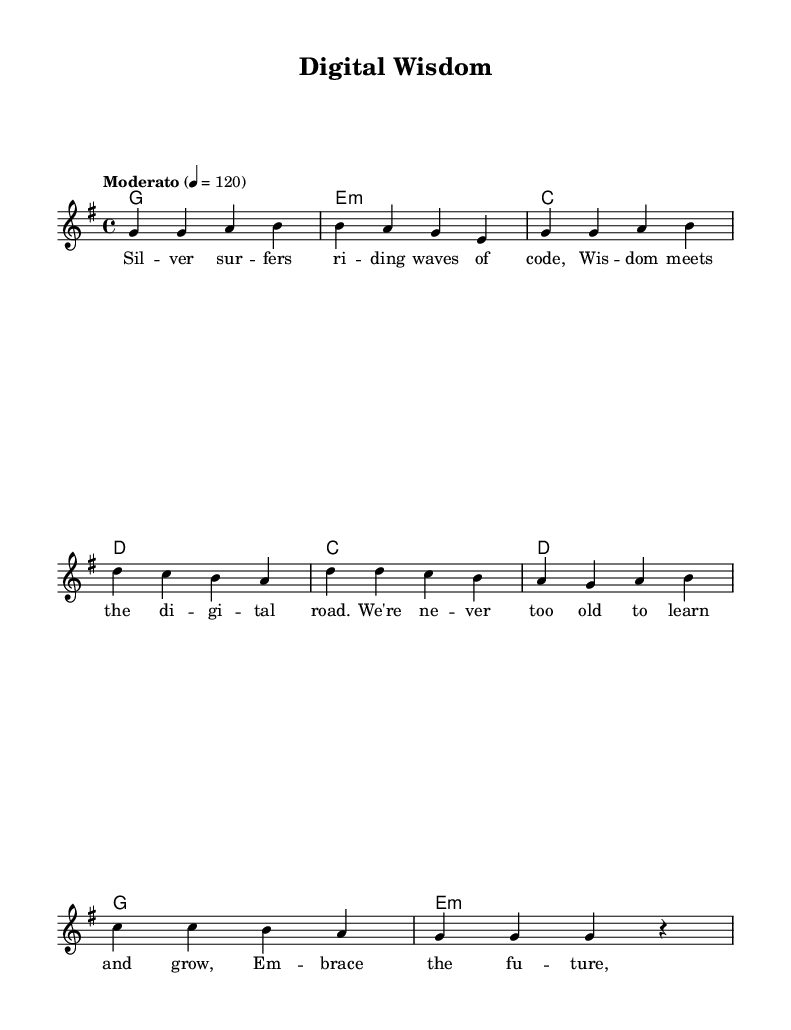What is the key signature of this music? The key signature is G major, which has one sharp (F#). This can be determined by looking at the key signature shown at the beginning of the staff.
Answer: G major What is the time signature of this music? The time signature is 4/4, indicating there are four beats in each measure and the quarter note receives one beat. This is indicated at the beginning of the sheet.
Answer: 4/4 What is the tempo marking in this music? The tempo marking is "Moderato," which typically suggests a moderate speed. The number 120 indicates the beats per minute (quarter note).
Answer: Moderato How many measures are in the verse section? The verse section contains four measures, which can be counted by observing the number of vertical lines separating the notes.
Answer: Four What chord follows the G major chord in the verse? The chord that follows the G major chord is E minor, as indicated in the chord changes written above the staff during the verse section.
Answer: E minor What are the lyrics associated with the chorus? The lyrics associated with the chorus express an optimistic message about learning and embracing the future, presented in lyric mode directly beneath the chorus notes.
Answer: "We're never too old to learn and grow, embrace the future, let knowledge flow." What type of song structure is used in this piece? The song structure used in this piece is verse-chorus form, where the verses establish themes and the chorus delivers a recurring message. This is indicated by the distinct sections labeled for verse and chorus.
Answer: Verse-Chorus 